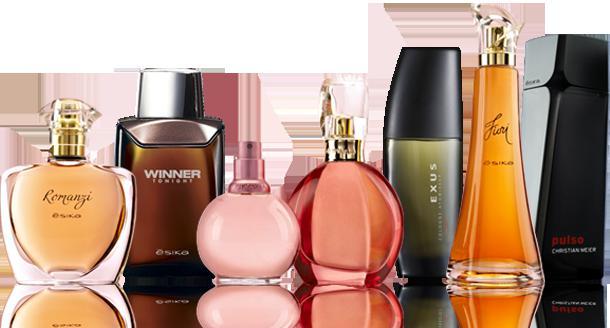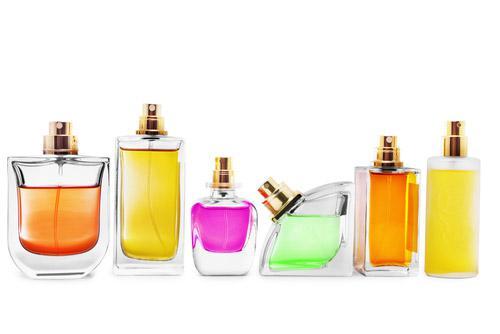The first image is the image on the left, the second image is the image on the right. Examine the images to the left and right. Is the description "Each image contains at least three different fragrance bottles." accurate? Answer yes or no. Yes. The first image is the image on the left, the second image is the image on the right. Given the left and right images, does the statement "A single vial of perfume is standing in each of the images." hold true? Answer yes or no. No. 